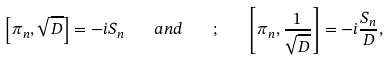Convert formula to latex. <formula><loc_0><loc_0><loc_500><loc_500>\left [ \pi _ { n } , \sqrt { D } \right ] = - i S _ { n } \quad a n d \quad ; \quad \left [ \pi _ { n } , { \frac { 1 } { \sqrt { D } } } \right ] = - i { \frac { S _ { n } } { D } } ,</formula> 